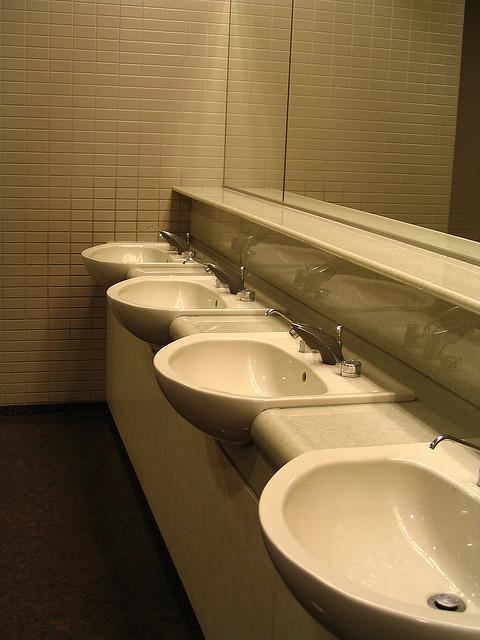How many sinks are here?
Give a very brief answer. 4. How many sinks can be seen?
Give a very brief answer. 4. 